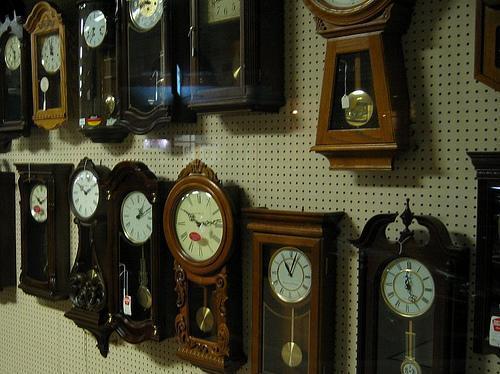How many clock faces can be seen?
Give a very brief answer. 12. How many clocks are there?
Give a very brief answer. 7. 